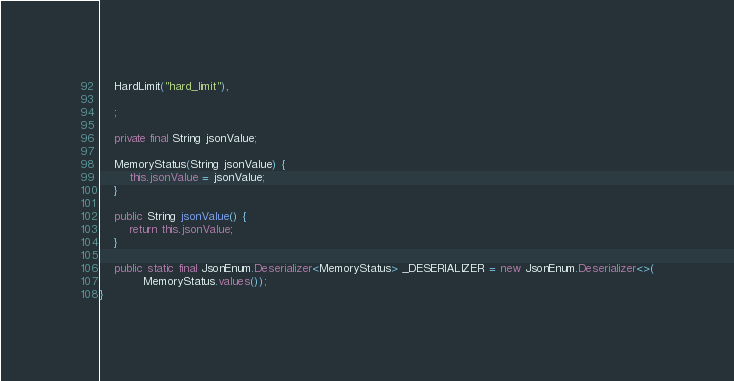Convert code to text. <code><loc_0><loc_0><loc_500><loc_500><_Java_>	HardLimit("hard_limit"),

	;

	private final String jsonValue;

	MemoryStatus(String jsonValue) {
		this.jsonValue = jsonValue;
	}

	public String jsonValue() {
		return this.jsonValue;
	}

	public static final JsonEnum.Deserializer<MemoryStatus> _DESERIALIZER = new JsonEnum.Deserializer<>(
			MemoryStatus.values());
}
</code> 